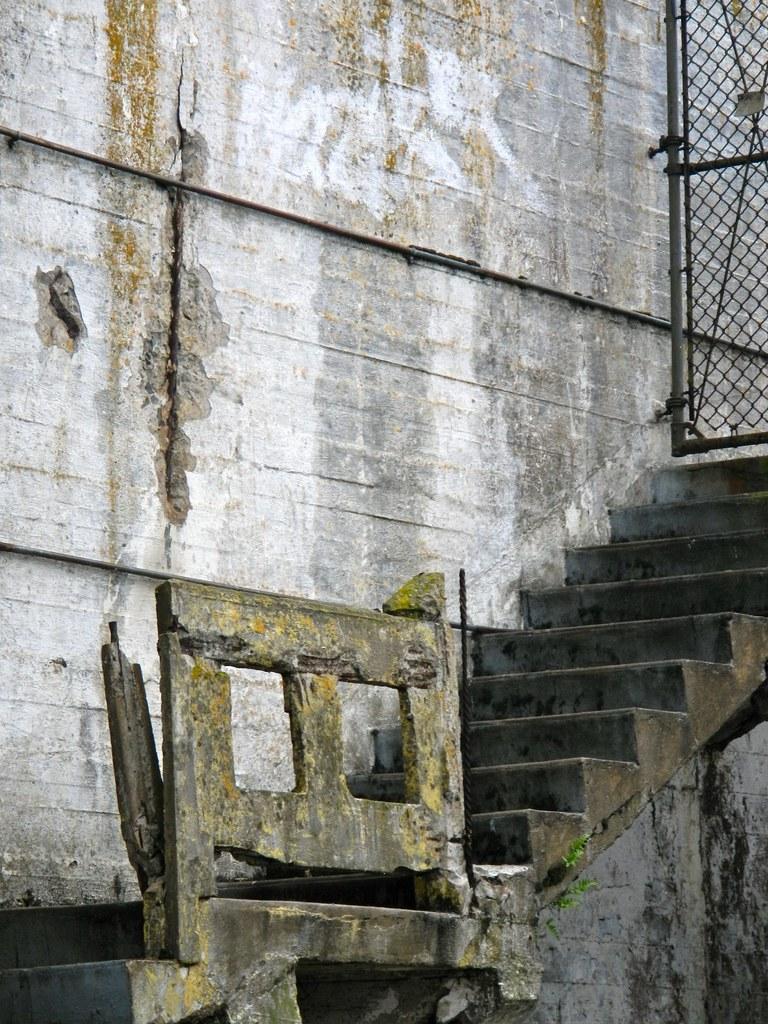Please provide a concise description of this image. In this picture we can see steps, walls, mesh and some objects. 